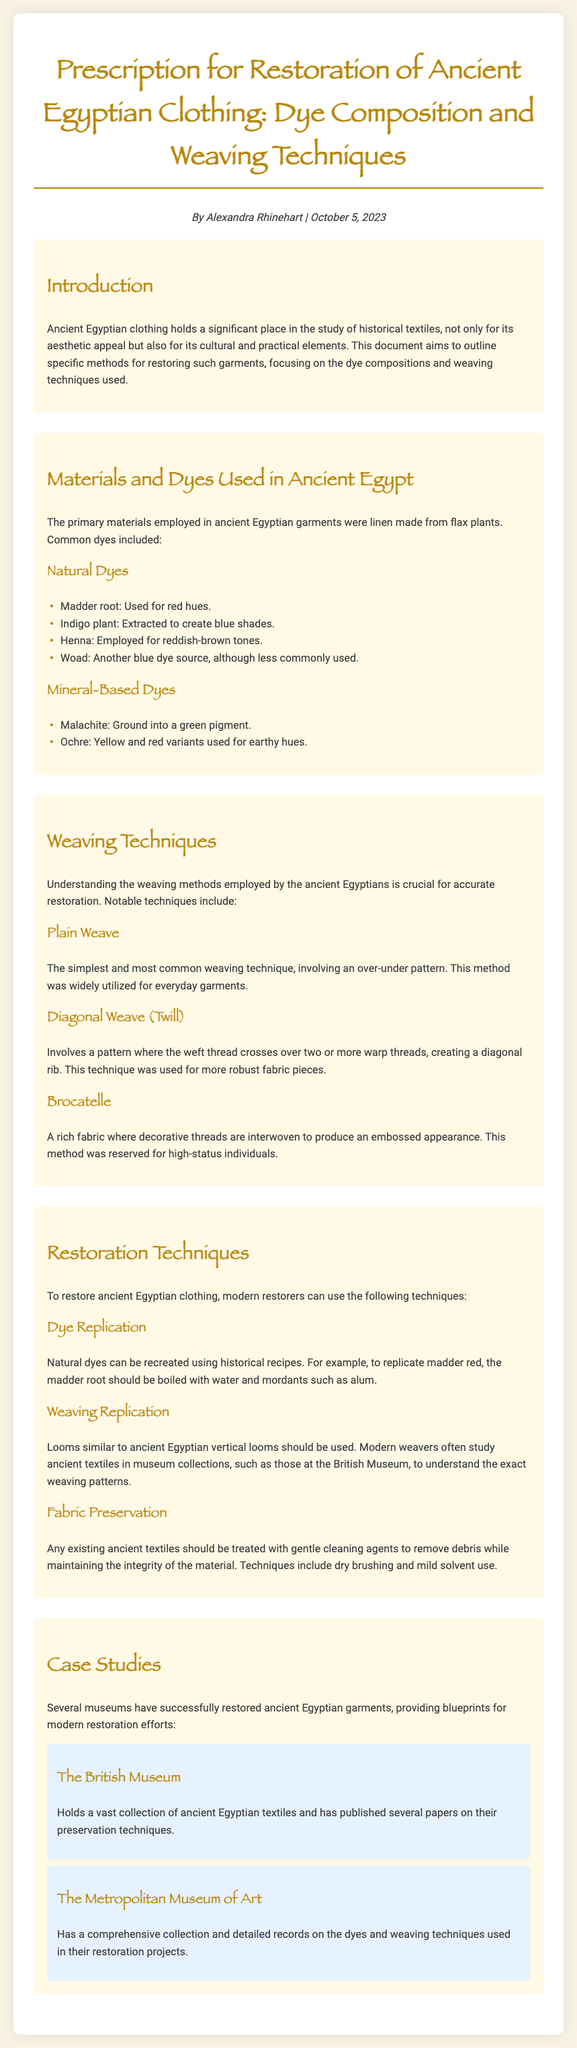What is the primary material used in ancient Egyptian garments? The document states that the primary materials employed in ancient Egyptian garments were linen made from flax plants.
Answer: linen What are the four natural dyes listed? The document specifically names madder root, indigo plant, henna, and woad as natural dyes used in ancient Egypt.
Answer: madder root, indigo plant, henna, woad What weaving technique is described as the simplest? According to the document, the simplest weaving technique is the plain weave, which involves an over-under pattern.
Answer: plain weave Which museum is mentioned as holding a vast collection of ancient Egyptian textiles? The document references the British Museum as a holder of a vast collection and has published papers on preservation techniques.
Answer: The British Museum How can natural dyes be replicated according to modern restoration techniques? The document mentions that natural dyes can be recreated using historical recipes, such as boiling the madder root with water and mordants like alum to replicate madder red.
Answer: boiling madder root with water and mordants like alum What is the purpose of dry brushing in fabric preservation? The document indicates that dry brushing is a technique used to gently clean ancient textiles and remove debris while maintaining the integrity of the material.
Answer: gently clean textiles and remove debris What is the more robust weaving technique mentioned? The document mentions diagonal weave (twill) as a method for creating a stronger fabric by having the weft thread cross over two or more warp threads.
Answer: diagonal weave (twill) What is the date of the document? The author-date section of the document specifies that it was published on October 5, 2023.
Answer: October 5, 2023 